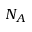Convert formula to latex. <formula><loc_0><loc_0><loc_500><loc_500>N _ { A }</formula> 